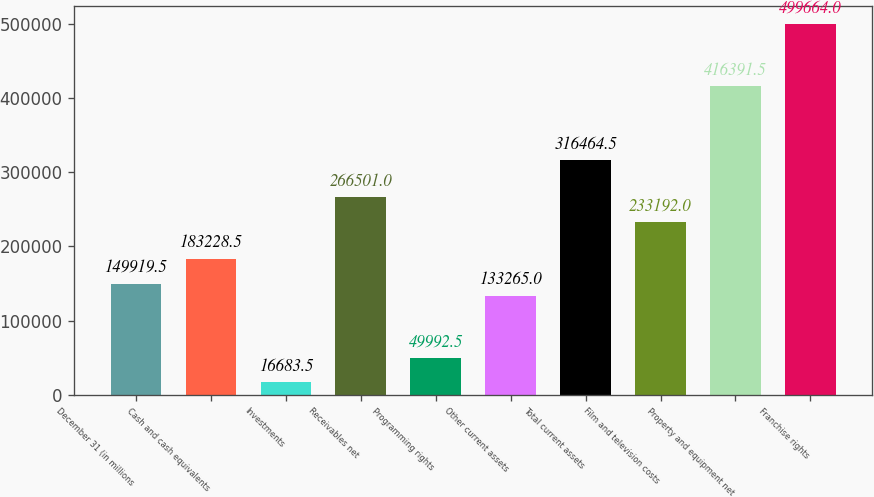Convert chart to OTSL. <chart><loc_0><loc_0><loc_500><loc_500><bar_chart><fcel>December 31 (in millions<fcel>Cash and cash equivalents<fcel>Investments<fcel>Receivables net<fcel>Programming rights<fcel>Other current assets<fcel>Total current assets<fcel>Film and television costs<fcel>Property and equipment net<fcel>Franchise rights<nl><fcel>149920<fcel>183228<fcel>16683.5<fcel>266501<fcel>49992.5<fcel>133265<fcel>316464<fcel>233192<fcel>416392<fcel>499664<nl></chart> 